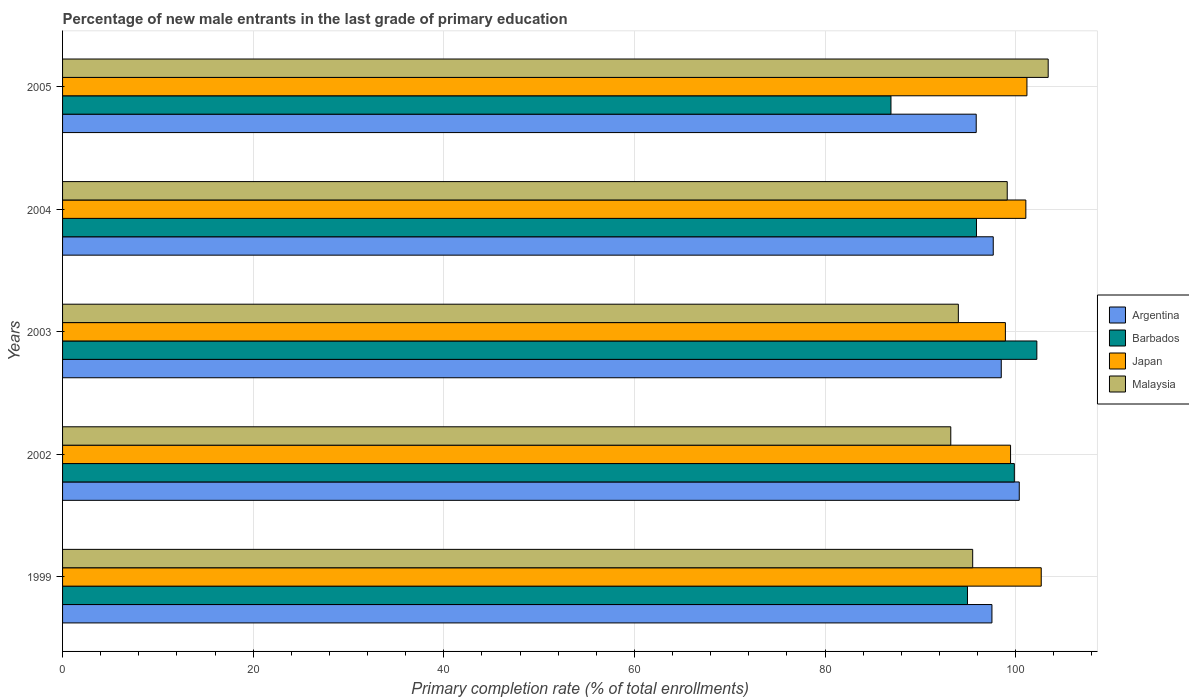Are the number of bars per tick equal to the number of legend labels?
Keep it short and to the point. Yes. Are the number of bars on each tick of the Y-axis equal?
Give a very brief answer. Yes. How many bars are there on the 4th tick from the top?
Give a very brief answer. 4. What is the label of the 5th group of bars from the top?
Offer a terse response. 1999. In how many cases, is the number of bars for a given year not equal to the number of legend labels?
Your answer should be very brief. 0. What is the percentage of new male entrants in Malaysia in 2003?
Give a very brief answer. 93.98. Across all years, what is the maximum percentage of new male entrants in Malaysia?
Make the answer very short. 103.41. Across all years, what is the minimum percentage of new male entrants in Argentina?
Ensure brevity in your answer.  95.86. What is the total percentage of new male entrants in Argentina in the graph?
Ensure brevity in your answer.  489.87. What is the difference between the percentage of new male entrants in Argentina in 1999 and that in 2003?
Make the answer very short. -0.98. What is the difference between the percentage of new male entrants in Malaysia in 2005 and the percentage of new male entrants in Japan in 1999?
Offer a terse response. 0.73. What is the average percentage of new male entrants in Japan per year?
Your response must be concise. 100.66. In the year 2003, what is the difference between the percentage of new male entrants in Japan and percentage of new male entrants in Barbados?
Ensure brevity in your answer.  -3.3. What is the ratio of the percentage of new male entrants in Argentina in 1999 to that in 2003?
Your answer should be very brief. 0.99. Is the percentage of new male entrants in Japan in 1999 less than that in 2005?
Give a very brief answer. No. What is the difference between the highest and the second highest percentage of new male entrants in Malaysia?
Provide a succinct answer. 4.3. What is the difference between the highest and the lowest percentage of new male entrants in Malaysia?
Provide a short and direct response. 10.22. Is the sum of the percentage of new male entrants in Japan in 2002 and 2005 greater than the maximum percentage of new male entrants in Argentina across all years?
Your response must be concise. Yes. Is it the case that in every year, the sum of the percentage of new male entrants in Argentina and percentage of new male entrants in Malaysia is greater than the sum of percentage of new male entrants in Japan and percentage of new male entrants in Barbados?
Offer a terse response. No. What does the 4th bar from the top in 2005 represents?
Your answer should be very brief. Argentina. What does the 3rd bar from the bottom in 1999 represents?
Keep it short and to the point. Japan. Are all the bars in the graph horizontal?
Keep it short and to the point. Yes. Are the values on the major ticks of X-axis written in scientific E-notation?
Offer a very short reply. No. Does the graph contain any zero values?
Offer a very short reply. No. How are the legend labels stacked?
Your answer should be compact. Vertical. What is the title of the graph?
Your response must be concise. Percentage of new male entrants in the last grade of primary education. What is the label or title of the X-axis?
Keep it short and to the point. Primary completion rate (% of total enrollments). What is the label or title of the Y-axis?
Keep it short and to the point. Years. What is the Primary completion rate (% of total enrollments) in Argentina in 1999?
Provide a short and direct response. 97.51. What is the Primary completion rate (% of total enrollments) of Barbados in 1999?
Your response must be concise. 94.94. What is the Primary completion rate (% of total enrollments) in Japan in 1999?
Keep it short and to the point. 102.68. What is the Primary completion rate (% of total enrollments) of Malaysia in 1999?
Your response must be concise. 95.49. What is the Primary completion rate (% of total enrollments) of Argentina in 2002?
Give a very brief answer. 100.37. What is the Primary completion rate (% of total enrollments) in Barbados in 2002?
Ensure brevity in your answer.  99.86. What is the Primary completion rate (% of total enrollments) of Japan in 2002?
Offer a very short reply. 99.46. What is the Primary completion rate (% of total enrollments) of Malaysia in 2002?
Provide a short and direct response. 93.19. What is the Primary completion rate (% of total enrollments) of Argentina in 2003?
Your answer should be compact. 98.49. What is the Primary completion rate (% of total enrollments) in Barbados in 2003?
Your answer should be very brief. 102.22. What is the Primary completion rate (% of total enrollments) in Japan in 2003?
Provide a short and direct response. 98.92. What is the Primary completion rate (% of total enrollments) of Malaysia in 2003?
Offer a very short reply. 93.98. What is the Primary completion rate (% of total enrollments) of Argentina in 2004?
Your answer should be compact. 97.65. What is the Primary completion rate (% of total enrollments) of Barbados in 2004?
Make the answer very short. 95.89. What is the Primary completion rate (% of total enrollments) of Japan in 2004?
Your answer should be compact. 101.07. What is the Primary completion rate (% of total enrollments) in Malaysia in 2004?
Provide a succinct answer. 99.11. What is the Primary completion rate (% of total enrollments) of Argentina in 2005?
Your answer should be very brief. 95.86. What is the Primary completion rate (% of total enrollments) in Barbados in 2005?
Offer a very short reply. 86.92. What is the Primary completion rate (% of total enrollments) of Japan in 2005?
Provide a succinct answer. 101.18. What is the Primary completion rate (% of total enrollments) in Malaysia in 2005?
Provide a succinct answer. 103.41. Across all years, what is the maximum Primary completion rate (% of total enrollments) of Argentina?
Your response must be concise. 100.37. Across all years, what is the maximum Primary completion rate (% of total enrollments) in Barbados?
Make the answer very short. 102.22. Across all years, what is the maximum Primary completion rate (% of total enrollments) in Japan?
Provide a succinct answer. 102.68. Across all years, what is the maximum Primary completion rate (% of total enrollments) of Malaysia?
Your answer should be very brief. 103.41. Across all years, what is the minimum Primary completion rate (% of total enrollments) of Argentina?
Your answer should be compact. 95.86. Across all years, what is the minimum Primary completion rate (% of total enrollments) of Barbados?
Provide a short and direct response. 86.92. Across all years, what is the minimum Primary completion rate (% of total enrollments) of Japan?
Your answer should be compact. 98.92. Across all years, what is the minimum Primary completion rate (% of total enrollments) in Malaysia?
Make the answer very short. 93.19. What is the total Primary completion rate (% of total enrollments) of Argentina in the graph?
Provide a succinct answer. 489.87. What is the total Primary completion rate (% of total enrollments) of Barbados in the graph?
Offer a very short reply. 479.82. What is the total Primary completion rate (% of total enrollments) of Japan in the graph?
Give a very brief answer. 503.31. What is the total Primary completion rate (% of total enrollments) of Malaysia in the graph?
Provide a short and direct response. 485.18. What is the difference between the Primary completion rate (% of total enrollments) in Argentina in 1999 and that in 2002?
Keep it short and to the point. -2.87. What is the difference between the Primary completion rate (% of total enrollments) in Barbados in 1999 and that in 2002?
Your response must be concise. -4.92. What is the difference between the Primary completion rate (% of total enrollments) of Japan in 1999 and that in 2002?
Make the answer very short. 3.22. What is the difference between the Primary completion rate (% of total enrollments) of Malaysia in 1999 and that in 2002?
Make the answer very short. 2.3. What is the difference between the Primary completion rate (% of total enrollments) in Argentina in 1999 and that in 2003?
Your response must be concise. -0.98. What is the difference between the Primary completion rate (% of total enrollments) of Barbados in 1999 and that in 2003?
Keep it short and to the point. -7.28. What is the difference between the Primary completion rate (% of total enrollments) in Japan in 1999 and that in 2003?
Your response must be concise. 3.76. What is the difference between the Primary completion rate (% of total enrollments) in Malaysia in 1999 and that in 2003?
Offer a very short reply. 1.5. What is the difference between the Primary completion rate (% of total enrollments) of Argentina in 1999 and that in 2004?
Offer a very short reply. -0.14. What is the difference between the Primary completion rate (% of total enrollments) in Barbados in 1999 and that in 2004?
Keep it short and to the point. -0.94. What is the difference between the Primary completion rate (% of total enrollments) in Japan in 1999 and that in 2004?
Give a very brief answer. 1.61. What is the difference between the Primary completion rate (% of total enrollments) in Malaysia in 1999 and that in 2004?
Offer a terse response. -3.62. What is the difference between the Primary completion rate (% of total enrollments) in Argentina in 1999 and that in 2005?
Provide a succinct answer. 1.65. What is the difference between the Primary completion rate (% of total enrollments) in Barbados in 1999 and that in 2005?
Your answer should be very brief. 8.03. What is the difference between the Primary completion rate (% of total enrollments) of Malaysia in 1999 and that in 2005?
Provide a short and direct response. -7.92. What is the difference between the Primary completion rate (% of total enrollments) in Argentina in 2002 and that in 2003?
Make the answer very short. 1.89. What is the difference between the Primary completion rate (% of total enrollments) of Barbados in 2002 and that in 2003?
Your answer should be compact. -2.36. What is the difference between the Primary completion rate (% of total enrollments) of Japan in 2002 and that in 2003?
Your answer should be compact. 0.54. What is the difference between the Primary completion rate (% of total enrollments) in Malaysia in 2002 and that in 2003?
Your answer should be very brief. -0.79. What is the difference between the Primary completion rate (% of total enrollments) in Argentina in 2002 and that in 2004?
Provide a short and direct response. 2.73. What is the difference between the Primary completion rate (% of total enrollments) of Barbados in 2002 and that in 2004?
Provide a short and direct response. 3.97. What is the difference between the Primary completion rate (% of total enrollments) in Japan in 2002 and that in 2004?
Provide a succinct answer. -1.6. What is the difference between the Primary completion rate (% of total enrollments) of Malaysia in 2002 and that in 2004?
Your answer should be very brief. -5.92. What is the difference between the Primary completion rate (% of total enrollments) of Argentina in 2002 and that in 2005?
Ensure brevity in your answer.  4.52. What is the difference between the Primary completion rate (% of total enrollments) of Barbados in 2002 and that in 2005?
Give a very brief answer. 12.94. What is the difference between the Primary completion rate (% of total enrollments) in Japan in 2002 and that in 2005?
Provide a succinct answer. -1.72. What is the difference between the Primary completion rate (% of total enrollments) of Malaysia in 2002 and that in 2005?
Offer a terse response. -10.22. What is the difference between the Primary completion rate (% of total enrollments) of Argentina in 2003 and that in 2004?
Your response must be concise. 0.84. What is the difference between the Primary completion rate (% of total enrollments) in Barbados in 2003 and that in 2004?
Offer a terse response. 6.33. What is the difference between the Primary completion rate (% of total enrollments) of Japan in 2003 and that in 2004?
Provide a short and direct response. -2.15. What is the difference between the Primary completion rate (% of total enrollments) in Malaysia in 2003 and that in 2004?
Your answer should be compact. -5.13. What is the difference between the Primary completion rate (% of total enrollments) of Argentina in 2003 and that in 2005?
Your answer should be very brief. 2.63. What is the difference between the Primary completion rate (% of total enrollments) in Barbados in 2003 and that in 2005?
Make the answer very short. 15.3. What is the difference between the Primary completion rate (% of total enrollments) in Japan in 2003 and that in 2005?
Ensure brevity in your answer.  -2.26. What is the difference between the Primary completion rate (% of total enrollments) of Malaysia in 2003 and that in 2005?
Your answer should be very brief. -9.43. What is the difference between the Primary completion rate (% of total enrollments) of Argentina in 2004 and that in 2005?
Keep it short and to the point. 1.79. What is the difference between the Primary completion rate (% of total enrollments) in Barbados in 2004 and that in 2005?
Provide a succinct answer. 8.97. What is the difference between the Primary completion rate (% of total enrollments) of Japan in 2004 and that in 2005?
Provide a short and direct response. -0.11. What is the difference between the Primary completion rate (% of total enrollments) in Malaysia in 2004 and that in 2005?
Give a very brief answer. -4.3. What is the difference between the Primary completion rate (% of total enrollments) of Argentina in 1999 and the Primary completion rate (% of total enrollments) of Barbados in 2002?
Your answer should be very brief. -2.35. What is the difference between the Primary completion rate (% of total enrollments) of Argentina in 1999 and the Primary completion rate (% of total enrollments) of Japan in 2002?
Offer a very short reply. -1.95. What is the difference between the Primary completion rate (% of total enrollments) in Argentina in 1999 and the Primary completion rate (% of total enrollments) in Malaysia in 2002?
Give a very brief answer. 4.32. What is the difference between the Primary completion rate (% of total enrollments) in Barbados in 1999 and the Primary completion rate (% of total enrollments) in Japan in 2002?
Offer a terse response. -4.52. What is the difference between the Primary completion rate (% of total enrollments) in Barbados in 1999 and the Primary completion rate (% of total enrollments) in Malaysia in 2002?
Ensure brevity in your answer.  1.75. What is the difference between the Primary completion rate (% of total enrollments) of Japan in 1999 and the Primary completion rate (% of total enrollments) of Malaysia in 2002?
Offer a terse response. 9.49. What is the difference between the Primary completion rate (% of total enrollments) in Argentina in 1999 and the Primary completion rate (% of total enrollments) in Barbados in 2003?
Offer a very short reply. -4.71. What is the difference between the Primary completion rate (% of total enrollments) in Argentina in 1999 and the Primary completion rate (% of total enrollments) in Japan in 2003?
Provide a succinct answer. -1.41. What is the difference between the Primary completion rate (% of total enrollments) in Argentina in 1999 and the Primary completion rate (% of total enrollments) in Malaysia in 2003?
Offer a terse response. 3.52. What is the difference between the Primary completion rate (% of total enrollments) in Barbados in 1999 and the Primary completion rate (% of total enrollments) in Japan in 2003?
Your response must be concise. -3.98. What is the difference between the Primary completion rate (% of total enrollments) of Barbados in 1999 and the Primary completion rate (% of total enrollments) of Malaysia in 2003?
Provide a short and direct response. 0.96. What is the difference between the Primary completion rate (% of total enrollments) in Japan in 1999 and the Primary completion rate (% of total enrollments) in Malaysia in 2003?
Provide a short and direct response. 8.7. What is the difference between the Primary completion rate (% of total enrollments) in Argentina in 1999 and the Primary completion rate (% of total enrollments) in Barbados in 2004?
Your answer should be very brief. 1.62. What is the difference between the Primary completion rate (% of total enrollments) in Argentina in 1999 and the Primary completion rate (% of total enrollments) in Japan in 2004?
Give a very brief answer. -3.56. What is the difference between the Primary completion rate (% of total enrollments) in Argentina in 1999 and the Primary completion rate (% of total enrollments) in Malaysia in 2004?
Provide a succinct answer. -1.61. What is the difference between the Primary completion rate (% of total enrollments) in Barbados in 1999 and the Primary completion rate (% of total enrollments) in Japan in 2004?
Give a very brief answer. -6.12. What is the difference between the Primary completion rate (% of total enrollments) in Barbados in 1999 and the Primary completion rate (% of total enrollments) in Malaysia in 2004?
Provide a short and direct response. -4.17. What is the difference between the Primary completion rate (% of total enrollments) of Japan in 1999 and the Primary completion rate (% of total enrollments) of Malaysia in 2004?
Keep it short and to the point. 3.57. What is the difference between the Primary completion rate (% of total enrollments) in Argentina in 1999 and the Primary completion rate (% of total enrollments) in Barbados in 2005?
Your answer should be very brief. 10.59. What is the difference between the Primary completion rate (% of total enrollments) in Argentina in 1999 and the Primary completion rate (% of total enrollments) in Japan in 2005?
Give a very brief answer. -3.67. What is the difference between the Primary completion rate (% of total enrollments) of Argentina in 1999 and the Primary completion rate (% of total enrollments) of Malaysia in 2005?
Offer a terse response. -5.9. What is the difference between the Primary completion rate (% of total enrollments) of Barbados in 1999 and the Primary completion rate (% of total enrollments) of Japan in 2005?
Offer a terse response. -6.24. What is the difference between the Primary completion rate (% of total enrollments) of Barbados in 1999 and the Primary completion rate (% of total enrollments) of Malaysia in 2005?
Make the answer very short. -8.47. What is the difference between the Primary completion rate (% of total enrollments) in Japan in 1999 and the Primary completion rate (% of total enrollments) in Malaysia in 2005?
Your answer should be compact. -0.73. What is the difference between the Primary completion rate (% of total enrollments) of Argentina in 2002 and the Primary completion rate (% of total enrollments) of Barbados in 2003?
Give a very brief answer. -1.84. What is the difference between the Primary completion rate (% of total enrollments) of Argentina in 2002 and the Primary completion rate (% of total enrollments) of Japan in 2003?
Your answer should be compact. 1.46. What is the difference between the Primary completion rate (% of total enrollments) in Argentina in 2002 and the Primary completion rate (% of total enrollments) in Malaysia in 2003?
Ensure brevity in your answer.  6.39. What is the difference between the Primary completion rate (% of total enrollments) in Barbados in 2002 and the Primary completion rate (% of total enrollments) in Japan in 2003?
Your response must be concise. 0.94. What is the difference between the Primary completion rate (% of total enrollments) in Barbados in 2002 and the Primary completion rate (% of total enrollments) in Malaysia in 2003?
Make the answer very short. 5.87. What is the difference between the Primary completion rate (% of total enrollments) of Japan in 2002 and the Primary completion rate (% of total enrollments) of Malaysia in 2003?
Offer a terse response. 5.48. What is the difference between the Primary completion rate (% of total enrollments) in Argentina in 2002 and the Primary completion rate (% of total enrollments) in Barbados in 2004?
Provide a short and direct response. 4.49. What is the difference between the Primary completion rate (% of total enrollments) of Argentina in 2002 and the Primary completion rate (% of total enrollments) of Japan in 2004?
Provide a succinct answer. -0.69. What is the difference between the Primary completion rate (% of total enrollments) of Argentina in 2002 and the Primary completion rate (% of total enrollments) of Malaysia in 2004?
Give a very brief answer. 1.26. What is the difference between the Primary completion rate (% of total enrollments) of Barbados in 2002 and the Primary completion rate (% of total enrollments) of Japan in 2004?
Your response must be concise. -1.21. What is the difference between the Primary completion rate (% of total enrollments) in Barbados in 2002 and the Primary completion rate (% of total enrollments) in Malaysia in 2004?
Your response must be concise. 0.75. What is the difference between the Primary completion rate (% of total enrollments) of Japan in 2002 and the Primary completion rate (% of total enrollments) of Malaysia in 2004?
Keep it short and to the point. 0.35. What is the difference between the Primary completion rate (% of total enrollments) in Argentina in 2002 and the Primary completion rate (% of total enrollments) in Barbados in 2005?
Give a very brief answer. 13.46. What is the difference between the Primary completion rate (% of total enrollments) of Argentina in 2002 and the Primary completion rate (% of total enrollments) of Japan in 2005?
Your response must be concise. -0.8. What is the difference between the Primary completion rate (% of total enrollments) of Argentina in 2002 and the Primary completion rate (% of total enrollments) of Malaysia in 2005?
Your response must be concise. -3.03. What is the difference between the Primary completion rate (% of total enrollments) in Barbados in 2002 and the Primary completion rate (% of total enrollments) in Japan in 2005?
Keep it short and to the point. -1.32. What is the difference between the Primary completion rate (% of total enrollments) in Barbados in 2002 and the Primary completion rate (% of total enrollments) in Malaysia in 2005?
Make the answer very short. -3.55. What is the difference between the Primary completion rate (% of total enrollments) in Japan in 2002 and the Primary completion rate (% of total enrollments) in Malaysia in 2005?
Provide a short and direct response. -3.95. What is the difference between the Primary completion rate (% of total enrollments) in Argentina in 2003 and the Primary completion rate (% of total enrollments) in Barbados in 2004?
Give a very brief answer. 2.6. What is the difference between the Primary completion rate (% of total enrollments) in Argentina in 2003 and the Primary completion rate (% of total enrollments) in Japan in 2004?
Offer a terse response. -2.58. What is the difference between the Primary completion rate (% of total enrollments) in Argentina in 2003 and the Primary completion rate (% of total enrollments) in Malaysia in 2004?
Ensure brevity in your answer.  -0.63. What is the difference between the Primary completion rate (% of total enrollments) in Barbados in 2003 and the Primary completion rate (% of total enrollments) in Japan in 2004?
Offer a terse response. 1.15. What is the difference between the Primary completion rate (% of total enrollments) of Barbados in 2003 and the Primary completion rate (% of total enrollments) of Malaysia in 2004?
Give a very brief answer. 3.11. What is the difference between the Primary completion rate (% of total enrollments) in Japan in 2003 and the Primary completion rate (% of total enrollments) in Malaysia in 2004?
Keep it short and to the point. -0.19. What is the difference between the Primary completion rate (% of total enrollments) of Argentina in 2003 and the Primary completion rate (% of total enrollments) of Barbados in 2005?
Offer a very short reply. 11.57. What is the difference between the Primary completion rate (% of total enrollments) of Argentina in 2003 and the Primary completion rate (% of total enrollments) of Japan in 2005?
Ensure brevity in your answer.  -2.69. What is the difference between the Primary completion rate (% of total enrollments) of Argentina in 2003 and the Primary completion rate (% of total enrollments) of Malaysia in 2005?
Ensure brevity in your answer.  -4.92. What is the difference between the Primary completion rate (% of total enrollments) in Barbados in 2003 and the Primary completion rate (% of total enrollments) in Japan in 2005?
Offer a very short reply. 1.04. What is the difference between the Primary completion rate (% of total enrollments) in Barbados in 2003 and the Primary completion rate (% of total enrollments) in Malaysia in 2005?
Your answer should be very brief. -1.19. What is the difference between the Primary completion rate (% of total enrollments) of Japan in 2003 and the Primary completion rate (% of total enrollments) of Malaysia in 2005?
Give a very brief answer. -4.49. What is the difference between the Primary completion rate (% of total enrollments) of Argentina in 2004 and the Primary completion rate (% of total enrollments) of Barbados in 2005?
Your answer should be compact. 10.73. What is the difference between the Primary completion rate (% of total enrollments) in Argentina in 2004 and the Primary completion rate (% of total enrollments) in Japan in 2005?
Ensure brevity in your answer.  -3.53. What is the difference between the Primary completion rate (% of total enrollments) of Argentina in 2004 and the Primary completion rate (% of total enrollments) of Malaysia in 2005?
Provide a short and direct response. -5.76. What is the difference between the Primary completion rate (% of total enrollments) of Barbados in 2004 and the Primary completion rate (% of total enrollments) of Japan in 2005?
Your answer should be compact. -5.29. What is the difference between the Primary completion rate (% of total enrollments) of Barbados in 2004 and the Primary completion rate (% of total enrollments) of Malaysia in 2005?
Give a very brief answer. -7.52. What is the difference between the Primary completion rate (% of total enrollments) in Japan in 2004 and the Primary completion rate (% of total enrollments) in Malaysia in 2005?
Ensure brevity in your answer.  -2.34. What is the average Primary completion rate (% of total enrollments) in Argentina per year?
Your answer should be compact. 97.97. What is the average Primary completion rate (% of total enrollments) in Barbados per year?
Offer a terse response. 95.96. What is the average Primary completion rate (% of total enrollments) in Japan per year?
Offer a very short reply. 100.66. What is the average Primary completion rate (% of total enrollments) in Malaysia per year?
Your response must be concise. 97.04. In the year 1999, what is the difference between the Primary completion rate (% of total enrollments) in Argentina and Primary completion rate (% of total enrollments) in Barbados?
Provide a succinct answer. 2.56. In the year 1999, what is the difference between the Primary completion rate (% of total enrollments) of Argentina and Primary completion rate (% of total enrollments) of Japan?
Give a very brief answer. -5.17. In the year 1999, what is the difference between the Primary completion rate (% of total enrollments) in Argentina and Primary completion rate (% of total enrollments) in Malaysia?
Your answer should be very brief. 2.02. In the year 1999, what is the difference between the Primary completion rate (% of total enrollments) of Barbados and Primary completion rate (% of total enrollments) of Japan?
Offer a terse response. -7.74. In the year 1999, what is the difference between the Primary completion rate (% of total enrollments) of Barbados and Primary completion rate (% of total enrollments) of Malaysia?
Offer a very short reply. -0.55. In the year 1999, what is the difference between the Primary completion rate (% of total enrollments) of Japan and Primary completion rate (% of total enrollments) of Malaysia?
Provide a short and direct response. 7.19. In the year 2002, what is the difference between the Primary completion rate (% of total enrollments) in Argentina and Primary completion rate (% of total enrollments) in Barbados?
Ensure brevity in your answer.  0.52. In the year 2002, what is the difference between the Primary completion rate (% of total enrollments) in Argentina and Primary completion rate (% of total enrollments) in Japan?
Provide a succinct answer. 0.91. In the year 2002, what is the difference between the Primary completion rate (% of total enrollments) in Argentina and Primary completion rate (% of total enrollments) in Malaysia?
Your response must be concise. 7.19. In the year 2002, what is the difference between the Primary completion rate (% of total enrollments) in Barbados and Primary completion rate (% of total enrollments) in Japan?
Offer a terse response. 0.4. In the year 2002, what is the difference between the Primary completion rate (% of total enrollments) in Barbados and Primary completion rate (% of total enrollments) in Malaysia?
Your answer should be very brief. 6.67. In the year 2002, what is the difference between the Primary completion rate (% of total enrollments) in Japan and Primary completion rate (% of total enrollments) in Malaysia?
Make the answer very short. 6.27. In the year 2003, what is the difference between the Primary completion rate (% of total enrollments) of Argentina and Primary completion rate (% of total enrollments) of Barbados?
Your answer should be very brief. -3.73. In the year 2003, what is the difference between the Primary completion rate (% of total enrollments) in Argentina and Primary completion rate (% of total enrollments) in Japan?
Keep it short and to the point. -0.43. In the year 2003, what is the difference between the Primary completion rate (% of total enrollments) in Argentina and Primary completion rate (% of total enrollments) in Malaysia?
Your answer should be compact. 4.5. In the year 2003, what is the difference between the Primary completion rate (% of total enrollments) of Barbados and Primary completion rate (% of total enrollments) of Japan?
Provide a succinct answer. 3.3. In the year 2003, what is the difference between the Primary completion rate (% of total enrollments) of Barbados and Primary completion rate (% of total enrollments) of Malaysia?
Offer a terse response. 8.24. In the year 2003, what is the difference between the Primary completion rate (% of total enrollments) in Japan and Primary completion rate (% of total enrollments) in Malaysia?
Ensure brevity in your answer.  4.94. In the year 2004, what is the difference between the Primary completion rate (% of total enrollments) in Argentina and Primary completion rate (% of total enrollments) in Barbados?
Keep it short and to the point. 1.76. In the year 2004, what is the difference between the Primary completion rate (% of total enrollments) of Argentina and Primary completion rate (% of total enrollments) of Japan?
Provide a succinct answer. -3.42. In the year 2004, what is the difference between the Primary completion rate (% of total enrollments) of Argentina and Primary completion rate (% of total enrollments) of Malaysia?
Your answer should be very brief. -1.47. In the year 2004, what is the difference between the Primary completion rate (% of total enrollments) in Barbados and Primary completion rate (% of total enrollments) in Japan?
Keep it short and to the point. -5.18. In the year 2004, what is the difference between the Primary completion rate (% of total enrollments) of Barbados and Primary completion rate (% of total enrollments) of Malaysia?
Provide a succinct answer. -3.23. In the year 2004, what is the difference between the Primary completion rate (% of total enrollments) in Japan and Primary completion rate (% of total enrollments) in Malaysia?
Keep it short and to the point. 1.95. In the year 2005, what is the difference between the Primary completion rate (% of total enrollments) of Argentina and Primary completion rate (% of total enrollments) of Barbados?
Ensure brevity in your answer.  8.94. In the year 2005, what is the difference between the Primary completion rate (% of total enrollments) of Argentina and Primary completion rate (% of total enrollments) of Japan?
Your answer should be very brief. -5.32. In the year 2005, what is the difference between the Primary completion rate (% of total enrollments) in Argentina and Primary completion rate (% of total enrollments) in Malaysia?
Keep it short and to the point. -7.55. In the year 2005, what is the difference between the Primary completion rate (% of total enrollments) in Barbados and Primary completion rate (% of total enrollments) in Japan?
Make the answer very short. -14.26. In the year 2005, what is the difference between the Primary completion rate (% of total enrollments) of Barbados and Primary completion rate (% of total enrollments) of Malaysia?
Your answer should be compact. -16.49. In the year 2005, what is the difference between the Primary completion rate (% of total enrollments) in Japan and Primary completion rate (% of total enrollments) in Malaysia?
Your response must be concise. -2.23. What is the ratio of the Primary completion rate (% of total enrollments) in Argentina in 1999 to that in 2002?
Make the answer very short. 0.97. What is the ratio of the Primary completion rate (% of total enrollments) in Barbados in 1999 to that in 2002?
Offer a terse response. 0.95. What is the ratio of the Primary completion rate (% of total enrollments) in Japan in 1999 to that in 2002?
Give a very brief answer. 1.03. What is the ratio of the Primary completion rate (% of total enrollments) in Malaysia in 1999 to that in 2002?
Keep it short and to the point. 1.02. What is the ratio of the Primary completion rate (% of total enrollments) of Barbados in 1999 to that in 2003?
Ensure brevity in your answer.  0.93. What is the ratio of the Primary completion rate (% of total enrollments) of Japan in 1999 to that in 2003?
Your answer should be compact. 1.04. What is the ratio of the Primary completion rate (% of total enrollments) of Malaysia in 1999 to that in 2003?
Your answer should be very brief. 1.02. What is the ratio of the Primary completion rate (% of total enrollments) of Barbados in 1999 to that in 2004?
Provide a succinct answer. 0.99. What is the ratio of the Primary completion rate (% of total enrollments) in Malaysia in 1999 to that in 2004?
Offer a very short reply. 0.96. What is the ratio of the Primary completion rate (% of total enrollments) of Argentina in 1999 to that in 2005?
Your answer should be very brief. 1.02. What is the ratio of the Primary completion rate (% of total enrollments) of Barbados in 1999 to that in 2005?
Ensure brevity in your answer.  1.09. What is the ratio of the Primary completion rate (% of total enrollments) in Japan in 1999 to that in 2005?
Ensure brevity in your answer.  1.01. What is the ratio of the Primary completion rate (% of total enrollments) in Malaysia in 1999 to that in 2005?
Your answer should be very brief. 0.92. What is the ratio of the Primary completion rate (% of total enrollments) in Argentina in 2002 to that in 2003?
Your response must be concise. 1.02. What is the ratio of the Primary completion rate (% of total enrollments) in Barbados in 2002 to that in 2003?
Provide a succinct answer. 0.98. What is the ratio of the Primary completion rate (% of total enrollments) in Japan in 2002 to that in 2003?
Your response must be concise. 1.01. What is the ratio of the Primary completion rate (% of total enrollments) in Argentina in 2002 to that in 2004?
Ensure brevity in your answer.  1.03. What is the ratio of the Primary completion rate (% of total enrollments) in Barbados in 2002 to that in 2004?
Your answer should be compact. 1.04. What is the ratio of the Primary completion rate (% of total enrollments) of Japan in 2002 to that in 2004?
Provide a short and direct response. 0.98. What is the ratio of the Primary completion rate (% of total enrollments) of Malaysia in 2002 to that in 2004?
Make the answer very short. 0.94. What is the ratio of the Primary completion rate (% of total enrollments) of Argentina in 2002 to that in 2005?
Your answer should be very brief. 1.05. What is the ratio of the Primary completion rate (% of total enrollments) in Barbados in 2002 to that in 2005?
Make the answer very short. 1.15. What is the ratio of the Primary completion rate (% of total enrollments) of Malaysia in 2002 to that in 2005?
Offer a terse response. 0.9. What is the ratio of the Primary completion rate (% of total enrollments) of Argentina in 2003 to that in 2004?
Make the answer very short. 1.01. What is the ratio of the Primary completion rate (% of total enrollments) in Barbados in 2003 to that in 2004?
Your response must be concise. 1.07. What is the ratio of the Primary completion rate (% of total enrollments) in Japan in 2003 to that in 2004?
Your answer should be very brief. 0.98. What is the ratio of the Primary completion rate (% of total enrollments) in Malaysia in 2003 to that in 2004?
Your answer should be very brief. 0.95. What is the ratio of the Primary completion rate (% of total enrollments) of Argentina in 2003 to that in 2005?
Your answer should be compact. 1.03. What is the ratio of the Primary completion rate (% of total enrollments) of Barbados in 2003 to that in 2005?
Keep it short and to the point. 1.18. What is the ratio of the Primary completion rate (% of total enrollments) of Japan in 2003 to that in 2005?
Your answer should be compact. 0.98. What is the ratio of the Primary completion rate (% of total enrollments) of Malaysia in 2003 to that in 2005?
Your answer should be very brief. 0.91. What is the ratio of the Primary completion rate (% of total enrollments) in Argentina in 2004 to that in 2005?
Your answer should be compact. 1.02. What is the ratio of the Primary completion rate (% of total enrollments) of Barbados in 2004 to that in 2005?
Ensure brevity in your answer.  1.1. What is the ratio of the Primary completion rate (% of total enrollments) of Japan in 2004 to that in 2005?
Offer a very short reply. 1. What is the ratio of the Primary completion rate (% of total enrollments) in Malaysia in 2004 to that in 2005?
Provide a short and direct response. 0.96. What is the difference between the highest and the second highest Primary completion rate (% of total enrollments) of Argentina?
Ensure brevity in your answer.  1.89. What is the difference between the highest and the second highest Primary completion rate (% of total enrollments) of Barbados?
Provide a short and direct response. 2.36. What is the difference between the highest and the second highest Primary completion rate (% of total enrollments) in Malaysia?
Give a very brief answer. 4.3. What is the difference between the highest and the lowest Primary completion rate (% of total enrollments) in Argentina?
Provide a succinct answer. 4.52. What is the difference between the highest and the lowest Primary completion rate (% of total enrollments) of Barbados?
Offer a terse response. 15.3. What is the difference between the highest and the lowest Primary completion rate (% of total enrollments) of Japan?
Provide a succinct answer. 3.76. What is the difference between the highest and the lowest Primary completion rate (% of total enrollments) of Malaysia?
Make the answer very short. 10.22. 